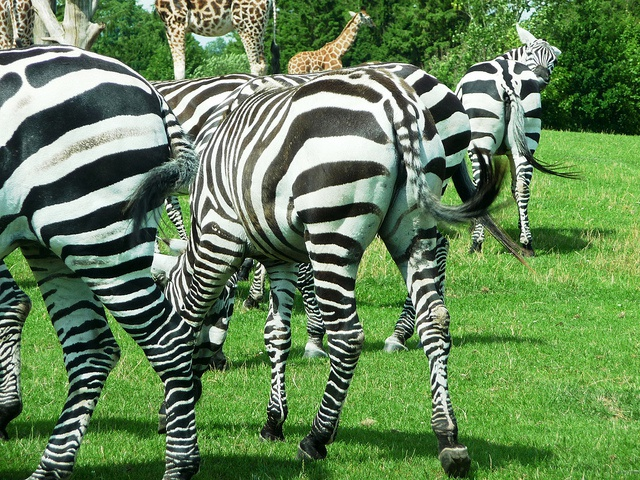Describe the objects in this image and their specific colors. I can see zebra in lightgray, black, ivory, gray, and darkgray tones, zebra in lightgray, black, ivory, and teal tones, zebra in lightgray, white, black, gray, and darkgray tones, zebra in lightgray, black, ivory, gray, and darkgray tones, and giraffe in lightgray, beige, darkgreen, gray, and black tones in this image. 